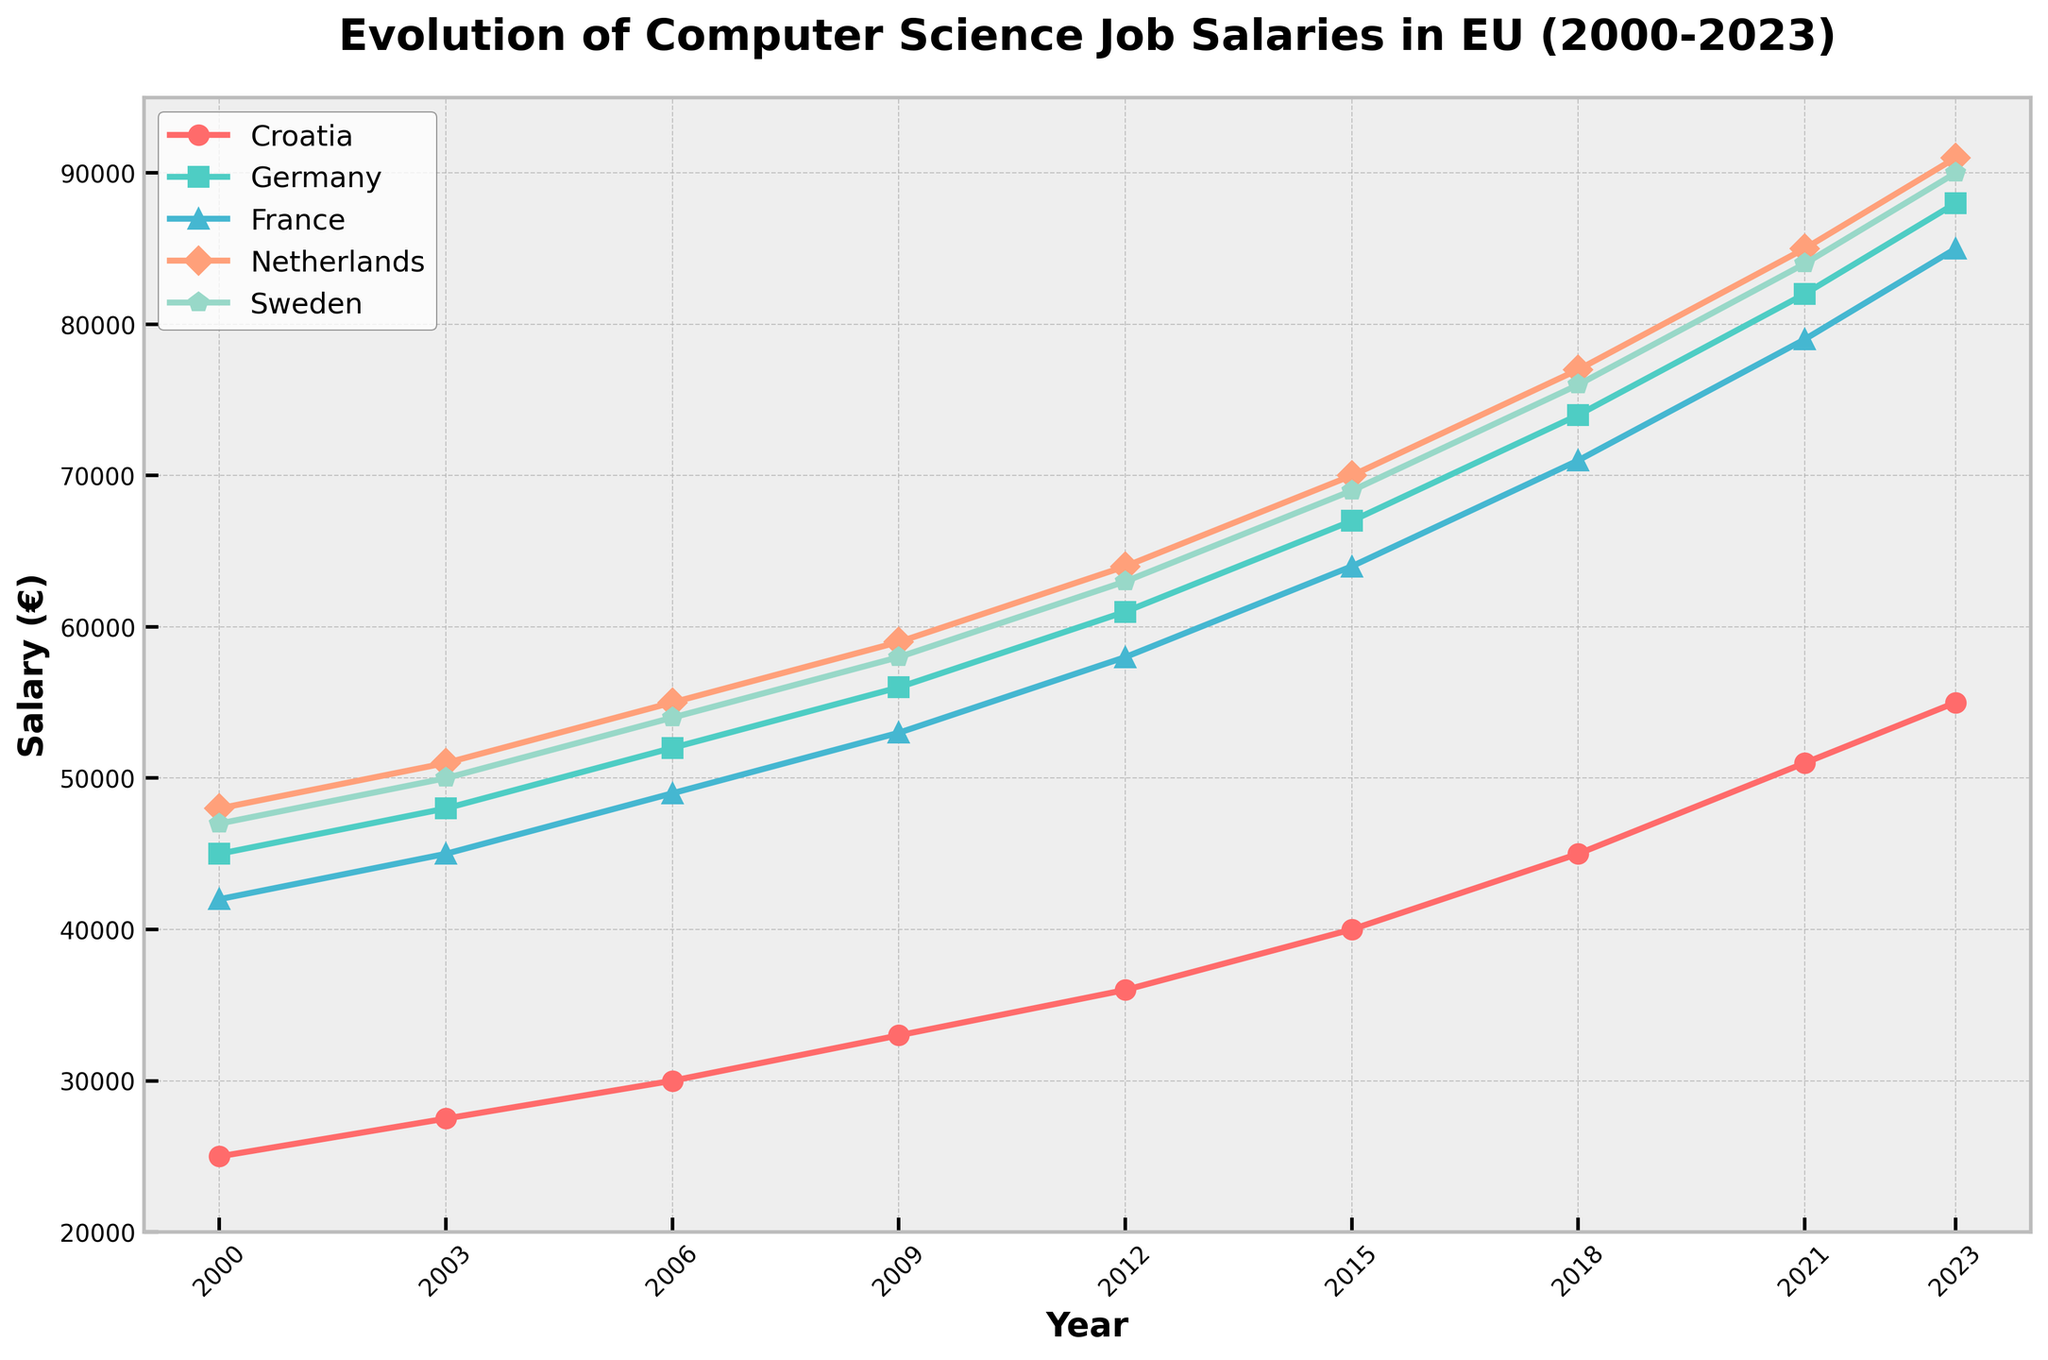Which country shows the highest salary increase from 2000 to 2023? To find the country with the highest salary increase, calculate the salary difference for each country between 2000 and 2023. Croatia: 55000 - 25000 = 30000, Germany: 88000 - 45000 = 43000, France: 85000 - 42000 = 43000, Netherlands: 91000 - 48000 = 43000, Sweden: 90000 - 47000 = 43000. Therefore, Germany, France, Netherlands, and Sweden all show the highest increase of 43000.
Answer: Germany, France, Netherlands, Sweden How has the salary in Croatia changed from 2000 to 2023? Track the Croatian salary points from 2000 (25000) to 2023 (55000) on the chart, showing an increase.
Answer: Increased from 25000 to 55000 In what year did Germany's computer science job salaries exceed 80000? Locate the point at which Germany's salary line crosses 80000. This occurs between 2018 (74000) and 2021 (82000), specifically in 2021.
Answer: 2021 Which country had the lowest salary in 2015? Examine the salaries in 2015 across all countries: Croatia (40000), Germany (67000), France (64000), Netherlands (70000), Sweden (69000). Croatia has the lowest salary in 2015.
Answer: Croatia What is the average computer science job salary in France for the years 2018 and 2023? Calculate the average of France's salaries for 2018 (71000) and 2023 (85000), i.e., (71000 + 85000) / 2 = 78000.
Answer: 78000 Compare the salary growth of Germany to that of Sweden between 2006 and 2015. Which country had a higher increase? Calculate salary growth for both countries: Germany from 52000 to 67000 (67000 - 52000 = 15000) and Sweden from 54000 to 69000 (69000 - 54000 = 15000). Both countries had the same increase of 15000 over this period.
Answer: Equal What year did the Netherlands surpass a salary of 60000? Find the year where the Netherlands' salary crosses 60000, which happens between 2006 (55000) and 2009 (59000). In 2009, it remains under 60000, so in 2012, it is above 60000.
Answer: 2012 Between 2000 and 2023, in which year does France show a more significant salary jump than any previous years? By observing the chart, France's salaries increased significantly between 2018 and 2021, jumping from 71000 to 79000 (8000 increase), which is the largest visible jump.
Answer: Between 2018 and 2021 How does the salary trend in Sweden compare to that in the Netherlands from 2009 to 2023? Comparing both countries, from 2009-2023 Sweden's salary rises from 58000 to 90000 (increase of 32000) while Netherlands' salary goes from 59000 to 91000 (an increase of 32000). Both have parallel trends with the same increase.
Answer: Similar trend, same increase 